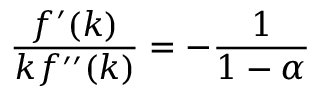Convert formula to latex. <formula><loc_0><loc_0><loc_500><loc_500>{ \frac { f ^ { \prime } ( k ) } { k f ^ { \prime \prime } ( k ) } } = - { \frac { 1 } { 1 - \alpha } }</formula> 